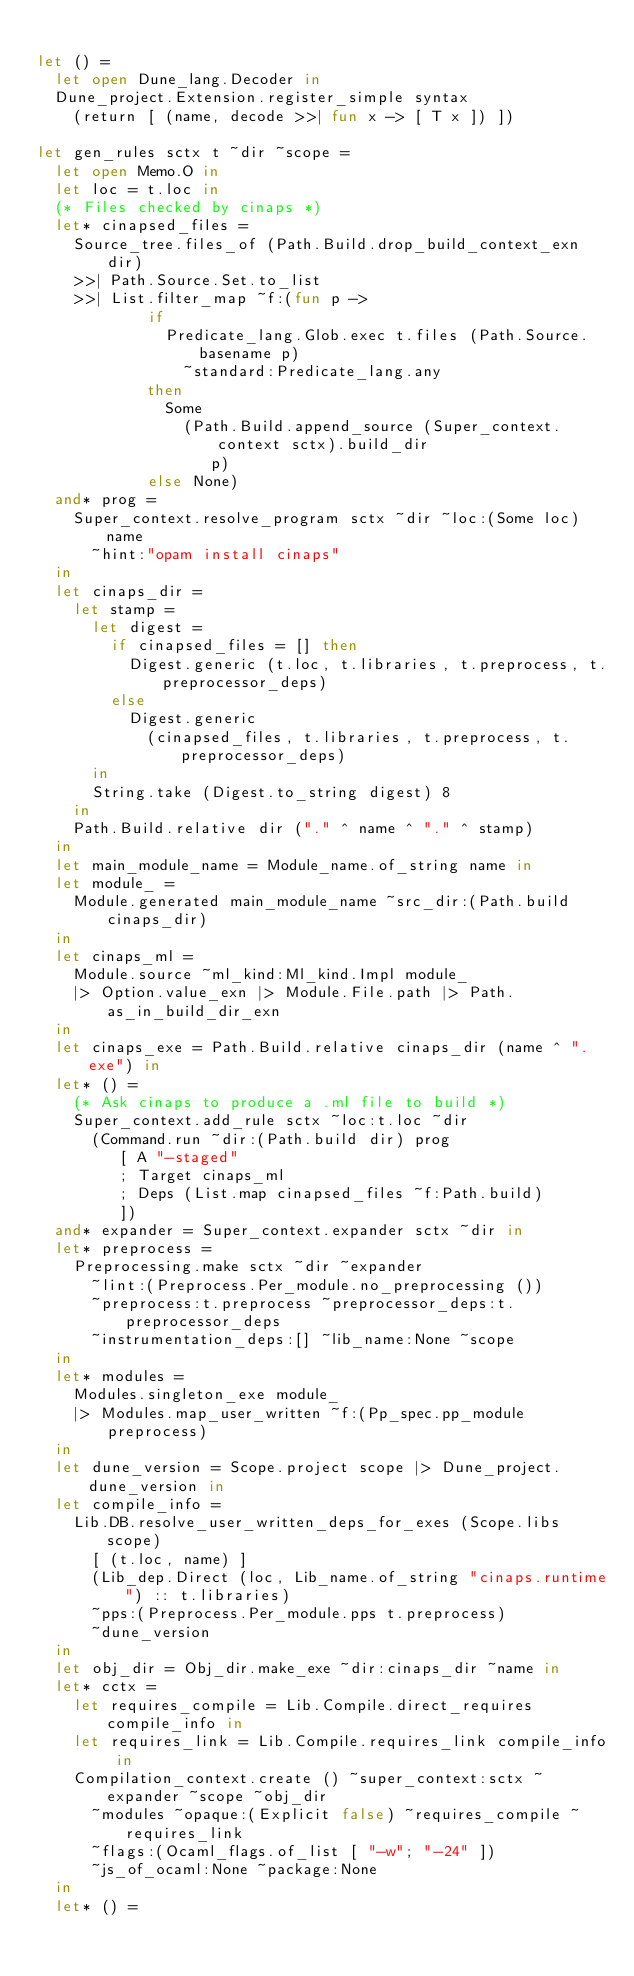Convert code to text. <code><loc_0><loc_0><loc_500><loc_500><_OCaml_>
let () =
  let open Dune_lang.Decoder in
  Dune_project.Extension.register_simple syntax
    (return [ (name, decode >>| fun x -> [ T x ]) ])

let gen_rules sctx t ~dir ~scope =
  let open Memo.O in
  let loc = t.loc in
  (* Files checked by cinaps *)
  let* cinapsed_files =
    Source_tree.files_of (Path.Build.drop_build_context_exn dir)
    >>| Path.Source.Set.to_list
    >>| List.filter_map ~f:(fun p ->
            if
              Predicate_lang.Glob.exec t.files (Path.Source.basename p)
                ~standard:Predicate_lang.any
            then
              Some
                (Path.Build.append_source (Super_context.context sctx).build_dir
                   p)
            else None)
  and* prog =
    Super_context.resolve_program sctx ~dir ~loc:(Some loc) name
      ~hint:"opam install cinaps"
  in
  let cinaps_dir =
    let stamp =
      let digest =
        if cinapsed_files = [] then
          Digest.generic (t.loc, t.libraries, t.preprocess, t.preprocessor_deps)
        else
          Digest.generic
            (cinapsed_files, t.libraries, t.preprocess, t.preprocessor_deps)
      in
      String.take (Digest.to_string digest) 8
    in
    Path.Build.relative dir ("." ^ name ^ "." ^ stamp)
  in
  let main_module_name = Module_name.of_string name in
  let module_ =
    Module.generated main_module_name ~src_dir:(Path.build cinaps_dir)
  in
  let cinaps_ml =
    Module.source ~ml_kind:Ml_kind.Impl module_
    |> Option.value_exn |> Module.File.path |> Path.as_in_build_dir_exn
  in
  let cinaps_exe = Path.Build.relative cinaps_dir (name ^ ".exe") in
  let* () =
    (* Ask cinaps to produce a .ml file to build *)
    Super_context.add_rule sctx ~loc:t.loc ~dir
      (Command.run ~dir:(Path.build dir) prog
         [ A "-staged"
         ; Target cinaps_ml
         ; Deps (List.map cinapsed_files ~f:Path.build)
         ])
  and* expander = Super_context.expander sctx ~dir in
  let* preprocess =
    Preprocessing.make sctx ~dir ~expander
      ~lint:(Preprocess.Per_module.no_preprocessing ())
      ~preprocess:t.preprocess ~preprocessor_deps:t.preprocessor_deps
      ~instrumentation_deps:[] ~lib_name:None ~scope
  in
  let* modules =
    Modules.singleton_exe module_
    |> Modules.map_user_written ~f:(Pp_spec.pp_module preprocess)
  in
  let dune_version = Scope.project scope |> Dune_project.dune_version in
  let compile_info =
    Lib.DB.resolve_user_written_deps_for_exes (Scope.libs scope)
      [ (t.loc, name) ]
      (Lib_dep.Direct (loc, Lib_name.of_string "cinaps.runtime") :: t.libraries)
      ~pps:(Preprocess.Per_module.pps t.preprocess)
      ~dune_version
  in
  let obj_dir = Obj_dir.make_exe ~dir:cinaps_dir ~name in
  let* cctx =
    let requires_compile = Lib.Compile.direct_requires compile_info in
    let requires_link = Lib.Compile.requires_link compile_info in
    Compilation_context.create () ~super_context:sctx ~expander ~scope ~obj_dir
      ~modules ~opaque:(Explicit false) ~requires_compile ~requires_link
      ~flags:(Ocaml_flags.of_list [ "-w"; "-24" ])
      ~js_of_ocaml:None ~package:None
  in
  let* () =</code> 